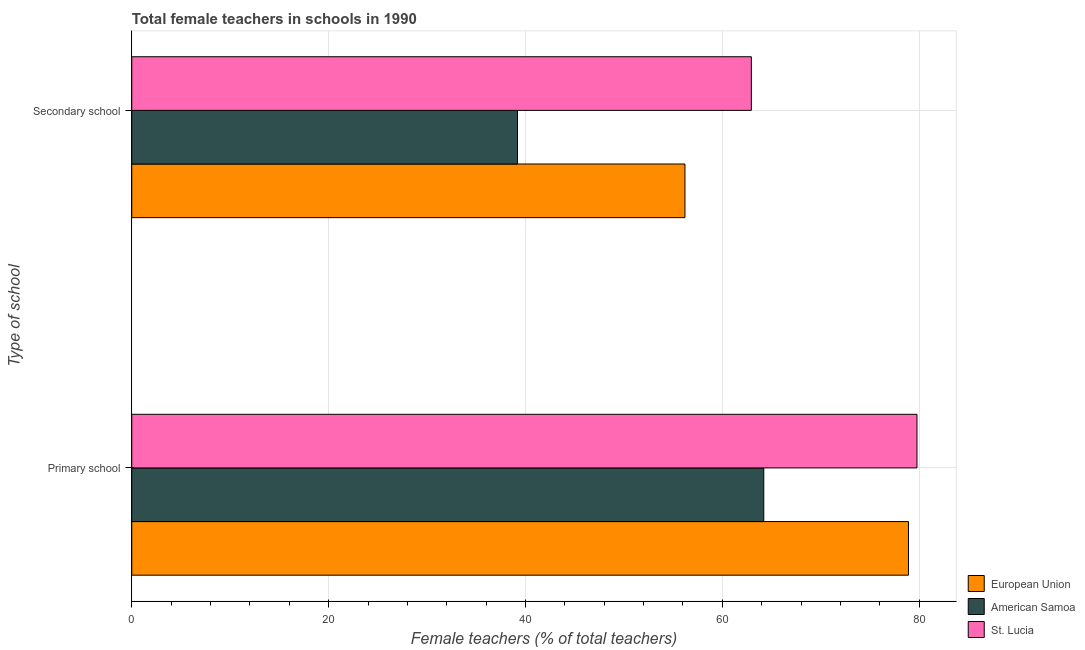How many groups of bars are there?
Make the answer very short. 2. Are the number of bars per tick equal to the number of legend labels?
Ensure brevity in your answer.  Yes. How many bars are there on the 1st tick from the top?
Offer a terse response. 3. How many bars are there on the 1st tick from the bottom?
Provide a short and direct response. 3. What is the label of the 1st group of bars from the top?
Offer a terse response. Secondary school. What is the percentage of female teachers in primary schools in American Samoa?
Your response must be concise. 64.21. Across all countries, what is the maximum percentage of female teachers in secondary schools?
Ensure brevity in your answer.  62.95. Across all countries, what is the minimum percentage of female teachers in primary schools?
Your answer should be compact. 64.21. In which country was the percentage of female teachers in primary schools maximum?
Ensure brevity in your answer.  St. Lucia. In which country was the percentage of female teachers in primary schools minimum?
Keep it short and to the point. American Samoa. What is the total percentage of female teachers in secondary schools in the graph?
Ensure brevity in your answer.  158.33. What is the difference between the percentage of female teachers in secondary schools in American Samoa and that in European Union?
Ensure brevity in your answer.  -17.01. What is the difference between the percentage of female teachers in primary schools in American Samoa and the percentage of female teachers in secondary schools in European Union?
Offer a very short reply. 8.01. What is the average percentage of female teachers in primary schools per country?
Make the answer very short. 74.3. What is the difference between the percentage of female teachers in primary schools and percentage of female teachers in secondary schools in European Union?
Your response must be concise. 22.71. What is the ratio of the percentage of female teachers in primary schools in St. Lucia to that in European Union?
Offer a very short reply. 1.01. What does the 1st bar from the top in Primary school represents?
Offer a very short reply. St. Lucia. How many bars are there?
Your answer should be very brief. 6. How many countries are there in the graph?
Offer a terse response. 3. Where does the legend appear in the graph?
Offer a terse response. Bottom right. How are the legend labels stacked?
Offer a terse response. Vertical. What is the title of the graph?
Make the answer very short. Total female teachers in schools in 1990. Does "Timor-Leste" appear as one of the legend labels in the graph?
Provide a short and direct response. No. What is the label or title of the X-axis?
Give a very brief answer. Female teachers (% of total teachers). What is the label or title of the Y-axis?
Offer a very short reply. Type of school. What is the Female teachers (% of total teachers) in European Union in Primary school?
Provide a succinct answer. 78.91. What is the Female teachers (% of total teachers) of American Samoa in Primary school?
Ensure brevity in your answer.  64.21. What is the Female teachers (% of total teachers) of St. Lucia in Primary school?
Your answer should be very brief. 79.77. What is the Female teachers (% of total teachers) in European Union in Secondary school?
Provide a succinct answer. 56.2. What is the Female teachers (% of total teachers) in American Samoa in Secondary school?
Keep it short and to the point. 39.19. What is the Female teachers (% of total teachers) in St. Lucia in Secondary school?
Your answer should be compact. 62.95. Across all Type of school, what is the maximum Female teachers (% of total teachers) in European Union?
Provide a succinct answer. 78.91. Across all Type of school, what is the maximum Female teachers (% of total teachers) of American Samoa?
Keep it short and to the point. 64.21. Across all Type of school, what is the maximum Female teachers (% of total teachers) in St. Lucia?
Provide a short and direct response. 79.77. Across all Type of school, what is the minimum Female teachers (% of total teachers) of European Union?
Make the answer very short. 56.2. Across all Type of school, what is the minimum Female teachers (% of total teachers) of American Samoa?
Keep it short and to the point. 39.19. Across all Type of school, what is the minimum Female teachers (% of total teachers) in St. Lucia?
Give a very brief answer. 62.95. What is the total Female teachers (% of total teachers) of European Union in the graph?
Make the answer very short. 135.11. What is the total Female teachers (% of total teachers) in American Samoa in the graph?
Offer a terse response. 103.4. What is the total Female teachers (% of total teachers) in St. Lucia in the graph?
Provide a succinct answer. 142.72. What is the difference between the Female teachers (% of total teachers) in European Union in Primary school and that in Secondary school?
Your answer should be very brief. 22.71. What is the difference between the Female teachers (% of total teachers) of American Samoa in Primary school and that in Secondary school?
Your answer should be very brief. 25.02. What is the difference between the Female teachers (% of total teachers) in St. Lucia in Primary school and that in Secondary school?
Make the answer very short. 16.83. What is the difference between the Female teachers (% of total teachers) in European Union in Primary school and the Female teachers (% of total teachers) in American Samoa in Secondary school?
Ensure brevity in your answer.  39.72. What is the difference between the Female teachers (% of total teachers) of European Union in Primary school and the Female teachers (% of total teachers) of St. Lucia in Secondary school?
Offer a very short reply. 15.96. What is the difference between the Female teachers (% of total teachers) in American Samoa in Primary school and the Female teachers (% of total teachers) in St. Lucia in Secondary school?
Your answer should be very brief. 1.26. What is the average Female teachers (% of total teachers) of European Union per Type of school?
Ensure brevity in your answer.  67.55. What is the average Female teachers (% of total teachers) of American Samoa per Type of school?
Offer a very short reply. 51.7. What is the average Female teachers (% of total teachers) of St. Lucia per Type of school?
Offer a terse response. 71.36. What is the difference between the Female teachers (% of total teachers) in European Union and Female teachers (% of total teachers) in American Samoa in Primary school?
Provide a succinct answer. 14.7. What is the difference between the Female teachers (% of total teachers) in European Union and Female teachers (% of total teachers) in St. Lucia in Primary school?
Make the answer very short. -0.86. What is the difference between the Female teachers (% of total teachers) in American Samoa and Female teachers (% of total teachers) in St. Lucia in Primary school?
Your answer should be very brief. -15.56. What is the difference between the Female teachers (% of total teachers) in European Union and Female teachers (% of total teachers) in American Samoa in Secondary school?
Your answer should be very brief. 17.01. What is the difference between the Female teachers (% of total teachers) in European Union and Female teachers (% of total teachers) in St. Lucia in Secondary school?
Ensure brevity in your answer.  -6.75. What is the difference between the Female teachers (% of total teachers) in American Samoa and Female teachers (% of total teachers) in St. Lucia in Secondary school?
Your response must be concise. -23.76. What is the ratio of the Female teachers (% of total teachers) in European Union in Primary school to that in Secondary school?
Offer a very short reply. 1.4. What is the ratio of the Female teachers (% of total teachers) in American Samoa in Primary school to that in Secondary school?
Provide a succinct answer. 1.64. What is the ratio of the Female teachers (% of total teachers) in St. Lucia in Primary school to that in Secondary school?
Your response must be concise. 1.27. What is the difference between the highest and the second highest Female teachers (% of total teachers) of European Union?
Your answer should be very brief. 22.71. What is the difference between the highest and the second highest Female teachers (% of total teachers) in American Samoa?
Offer a very short reply. 25.02. What is the difference between the highest and the second highest Female teachers (% of total teachers) in St. Lucia?
Offer a terse response. 16.83. What is the difference between the highest and the lowest Female teachers (% of total teachers) of European Union?
Ensure brevity in your answer.  22.71. What is the difference between the highest and the lowest Female teachers (% of total teachers) in American Samoa?
Your answer should be compact. 25.02. What is the difference between the highest and the lowest Female teachers (% of total teachers) in St. Lucia?
Provide a short and direct response. 16.83. 